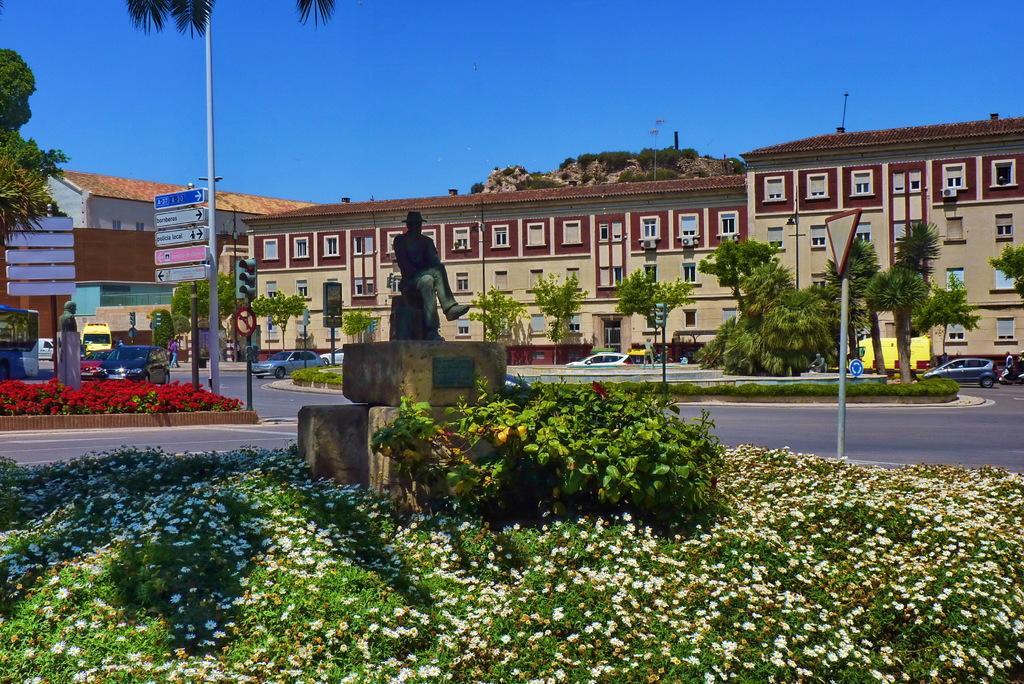How would you summarize this image in a sentence or two? In the foreground of this image, there is a man sculpture and on bottom there plants with flowers and in the background, there are plants, trees, poles, signal poles, buildings, sign boards, vehicles and the sky. 